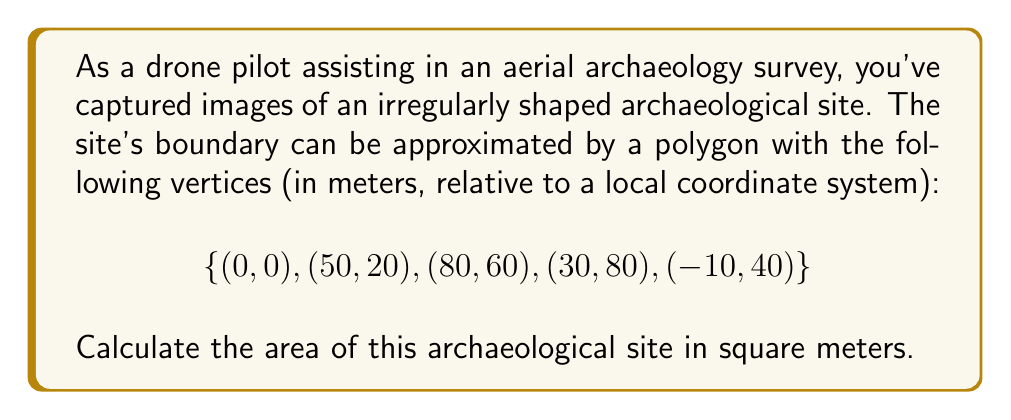Provide a solution to this math problem. To calculate the area of an irregularly shaped polygon, we can use the Shoelace formula (also known as the surveyor's formula). This method works for any polygon, whether it's convex or concave.

The Shoelace formula for a polygon with vertices $(x_1, y_1), (x_2, y_2), ..., (x_n, y_n)$ is:

$$A = \frac{1}{2}|\sum_{i=1}^{n-1} (x_iy_{i+1} + x_ny_1) - \sum_{i=1}^{n-1} (y_ix_{i+1} + y_nx_1)|$$

Where $A$ is the area, and $n$ is the number of vertices.

Let's apply this formula to our archaeological site:

1) First, let's list our vertices in order:
   $(x_1, y_1) = (0, 0)$
   $(x_2, y_2) = (50, 20)$
   $(x_3, y_3) = (80, 60)$
   $(x_4, y_4) = (30, 80)$
   $(x_5, y_5) = (-10, 40)$

2) Now, let's calculate the first sum:
   $\sum_{i=1}^{n-1} (x_iy_{i+1} + x_ny_1)$
   $= (0 \cdot 20) + (50 \cdot 60) + (80 \cdot 80) + (30 \cdot 40) + (-10 \cdot 0)$
   $= 0 + 3000 + 6400 + 1200 + 0 = 10600$

3) Next, calculate the second sum:
   $\sum_{i=1}^{n-1} (y_ix_{i+1} + y_nx_1)$
   $= (0 \cdot 50) + (20 \cdot 80) + (60 \cdot 30) + (80 \cdot -10) + (40 \cdot 0)$
   $= 0 + 1600 + 1800 - 800 + 0 = 2600$

4) Now, subtract the second sum from the first:
   $10600 - 2600 = 8000$

5) Finally, take the absolute value and divide by 2:
   $A = \frac{1}{2}|8000| = 4000$

Therefore, the area of the archaeological site is 4000 square meters.
Answer: The area of the archaeological site is 4000 square meters. 